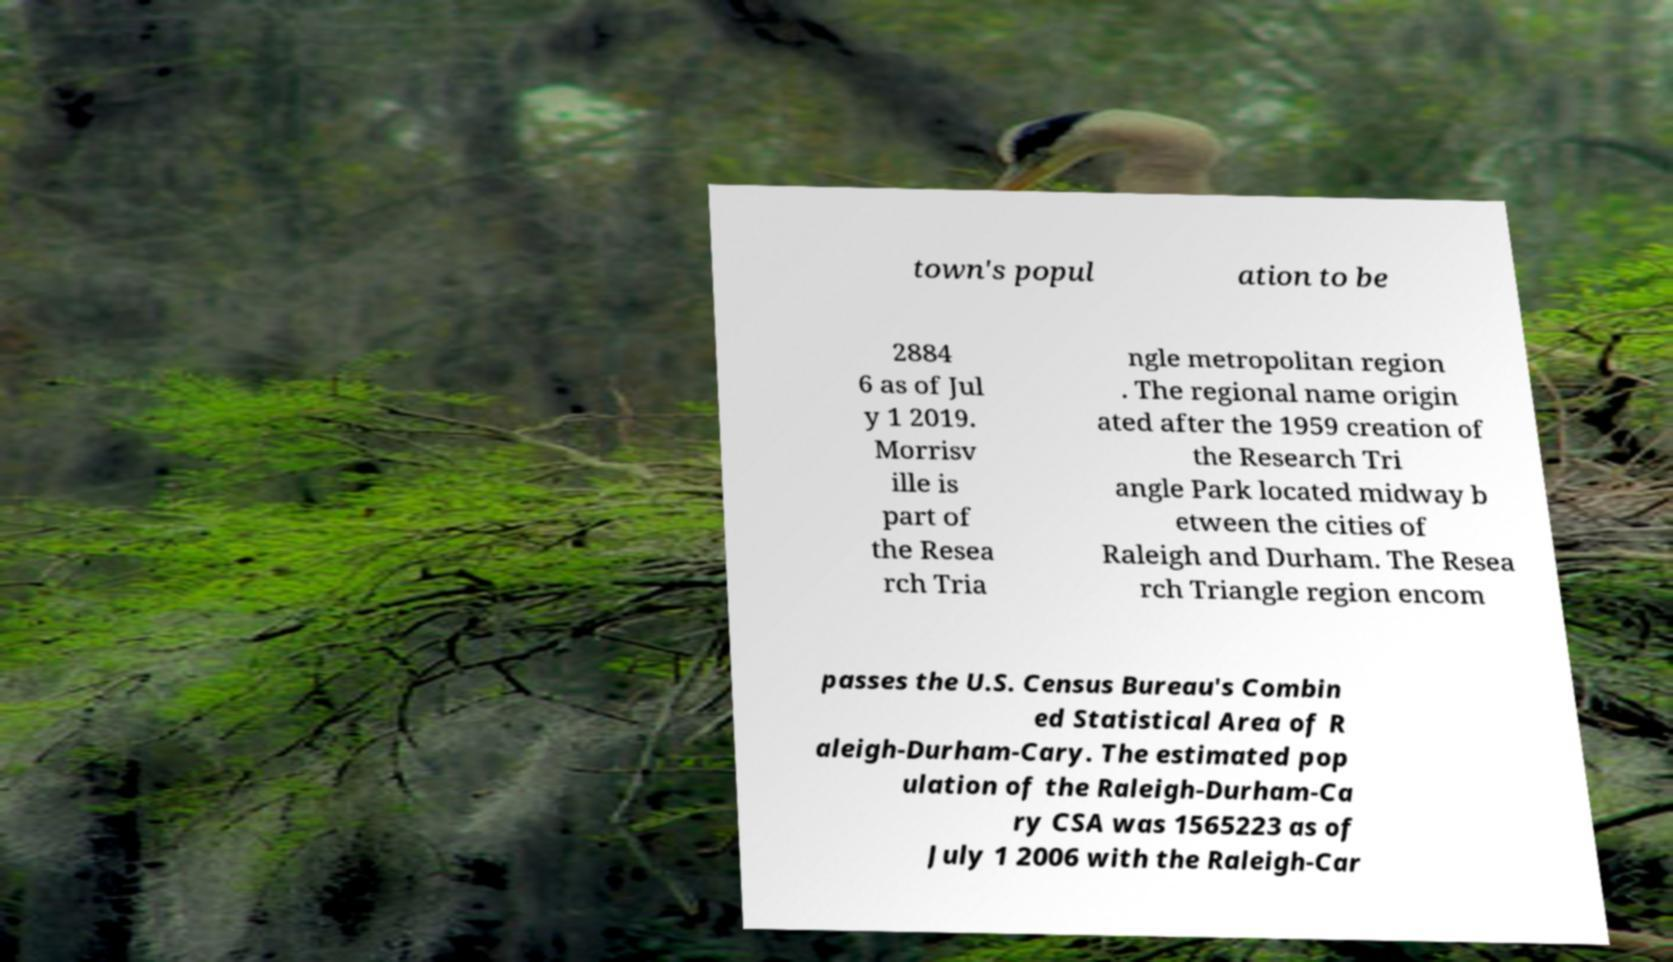I need the written content from this picture converted into text. Can you do that? town's popul ation to be 2884 6 as of Jul y 1 2019. Morrisv ille is part of the Resea rch Tria ngle metropolitan region . The regional name origin ated after the 1959 creation of the Research Tri angle Park located midway b etween the cities of Raleigh and Durham. The Resea rch Triangle region encom passes the U.S. Census Bureau's Combin ed Statistical Area of R aleigh-Durham-Cary. The estimated pop ulation of the Raleigh-Durham-Ca ry CSA was 1565223 as of July 1 2006 with the Raleigh-Car 